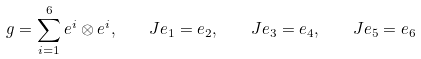Convert formula to latex. <formula><loc_0><loc_0><loc_500><loc_500>g = \sum _ { i = 1 } ^ { 6 } e ^ { i } \otimes e ^ { i } , \quad J e _ { 1 } = e _ { 2 } , \quad J e _ { 3 } = e _ { 4 } , \quad J e _ { 5 } = e _ { 6 }</formula> 